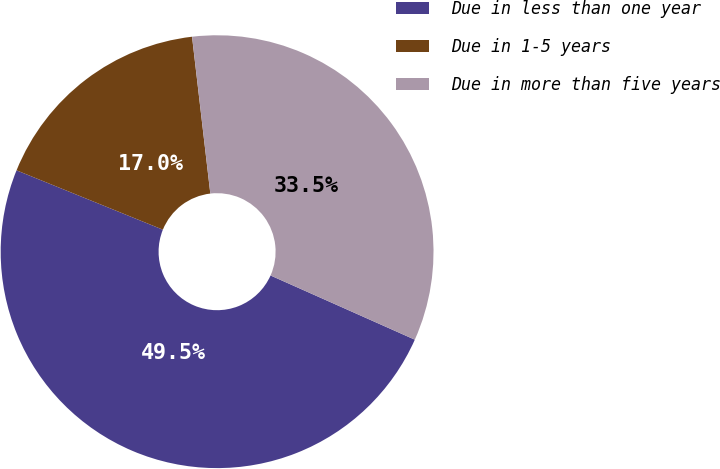<chart> <loc_0><loc_0><loc_500><loc_500><pie_chart><fcel>Due in less than one year<fcel>Due in 1-5 years<fcel>Due in more than five years<nl><fcel>49.47%<fcel>17.02%<fcel>33.51%<nl></chart> 